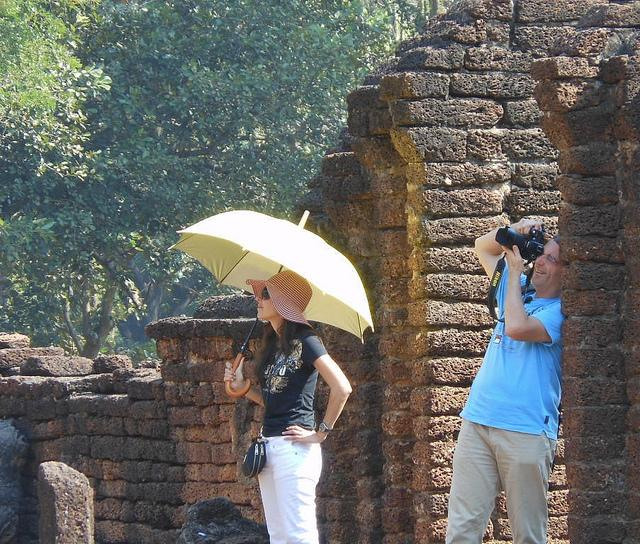What is he observing through the lens? Please explain your reasoning. unseen. The think he is looking at is in the sky and not in the image so it is uncertain. 